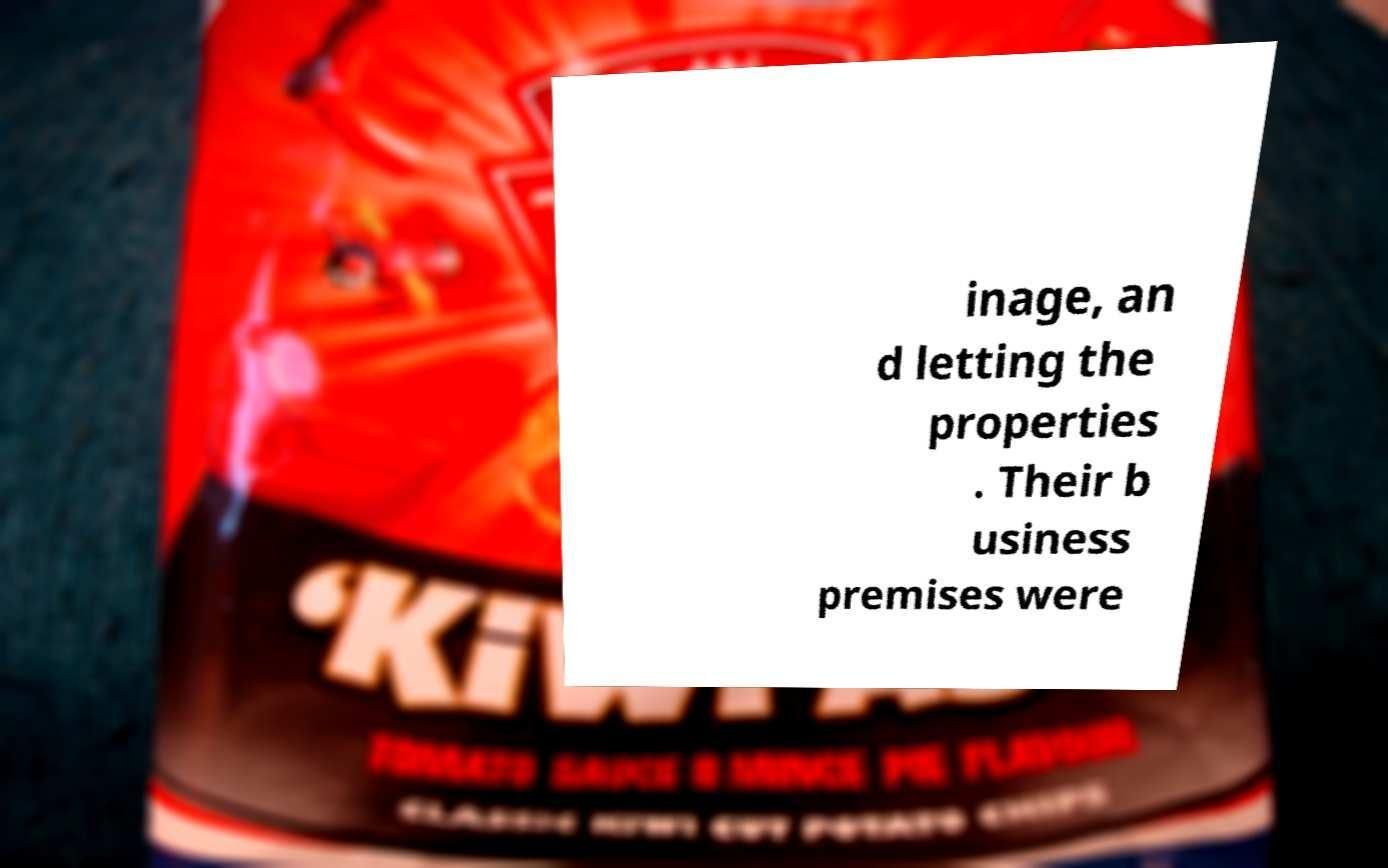Can you read and provide the text displayed in the image?This photo seems to have some interesting text. Can you extract and type it out for me? inage, an d letting the properties . Their b usiness premises were 